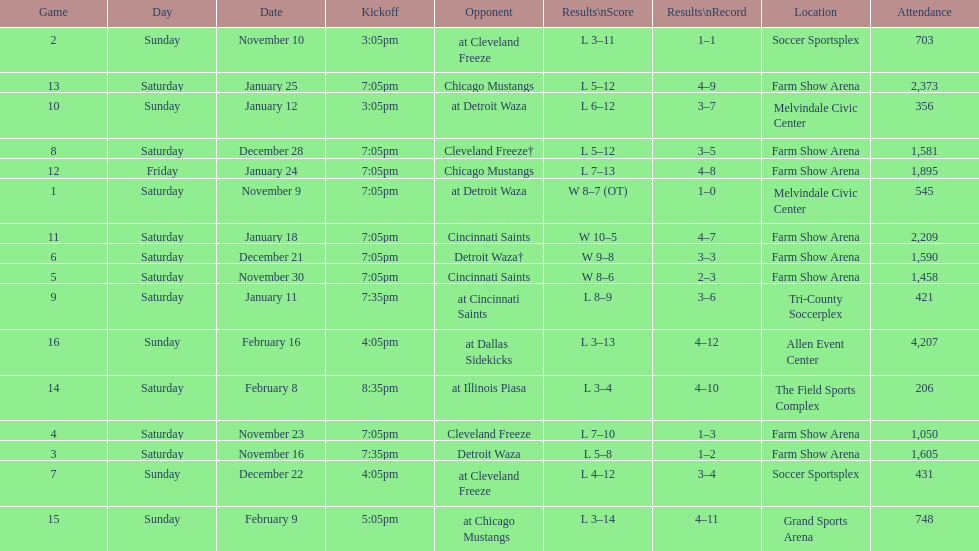How many times did the team play at home but did not win? 5. Can you give me this table as a dict? {'header': ['Game', 'Day', 'Date', 'Kickoff', 'Opponent', 'Results\\nScore', 'Results\\nRecord', 'Location', 'Attendance'], 'rows': [['2', 'Sunday', 'November 10', '3:05pm', 'at Cleveland Freeze', 'L 3–11', '1–1', 'Soccer Sportsplex', '703'], ['13', 'Saturday', 'January 25', '7:05pm', 'Chicago Mustangs', 'L 5–12', '4–9', 'Farm Show Arena', '2,373'], ['10', 'Sunday', 'January 12', '3:05pm', 'at Detroit Waza', 'L 6–12', '3–7', 'Melvindale Civic Center', '356'], ['8', 'Saturday', 'December 28', '7:05pm', 'Cleveland Freeze†', 'L 5–12', '3–5', 'Farm Show Arena', '1,581'], ['12', 'Friday', 'January 24', '7:05pm', 'Chicago Mustangs', 'L 7–13', '4–8', 'Farm Show Arena', '1,895'], ['1', 'Saturday', 'November 9', '7:05pm', 'at Detroit Waza', 'W 8–7 (OT)', '1–0', 'Melvindale Civic Center', '545'], ['11', 'Saturday', 'January 18', '7:05pm', 'Cincinnati Saints', 'W 10–5', '4–7', 'Farm Show Arena', '2,209'], ['6', 'Saturday', 'December 21', '7:05pm', 'Detroit Waza†', 'W 9–8', '3–3', 'Farm Show Arena', '1,590'], ['5', 'Saturday', 'November 30', '7:05pm', 'Cincinnati Saints', 'W 8–6', '2–3', 'Farm Show Arena', '1,458'], ['9', 'Saturday', 'January 11', '7:35pm', 'at Cincinnati Saints', 'L 8–9', '3–6', 'Tri-County Soccerplex', '421'], ['16', 'Sunday', 'February 16', '4:05pm', 'at Dallas Sidekicks', 'L 3–13', '4–12', 'Allen Event Center', '4,207'], ['14', 'Saturday', 'February 8', '8:35pm', 'at Illinois Piasa', 'L 3–4', '4–10', 'The Field Sports Complex', '206'], ['4', 'Saturday', 'November 23', '7:05pm', 'Cleveland Freeze', 'L 7–10', '1–3', 'Farm Show Arena', '1,050'], ['3', 'Saturday', 'November 16', '7:35pm', 'Detroit Waza', 'L 5–8', '1–2', 'Farm Show Arena', '1,605'], ['7', 'Sunday', 'December 22', '4:05pm', 'at Cleveland Freeze', 'L 4–12', '3–4', 'Soccer Sportsplex', '431'], ['15', 'Sunday', 'February 9', '5:05pm', 'at Chicago Mustangs', 'L 3–14', '4–11', 'Grand Sports Arena', '748']]} 